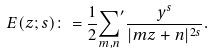Convert formula to latex. <formula><loc_0><loc_0><loc_500><loc_500>E ( z ; s ) \colon = \frac { 1 } { 2 } { \sum _ { m , n } } ^ { \prime } \frac { y ^ { s } } { | m z + n | ^ { 2 s } } .</formula> 